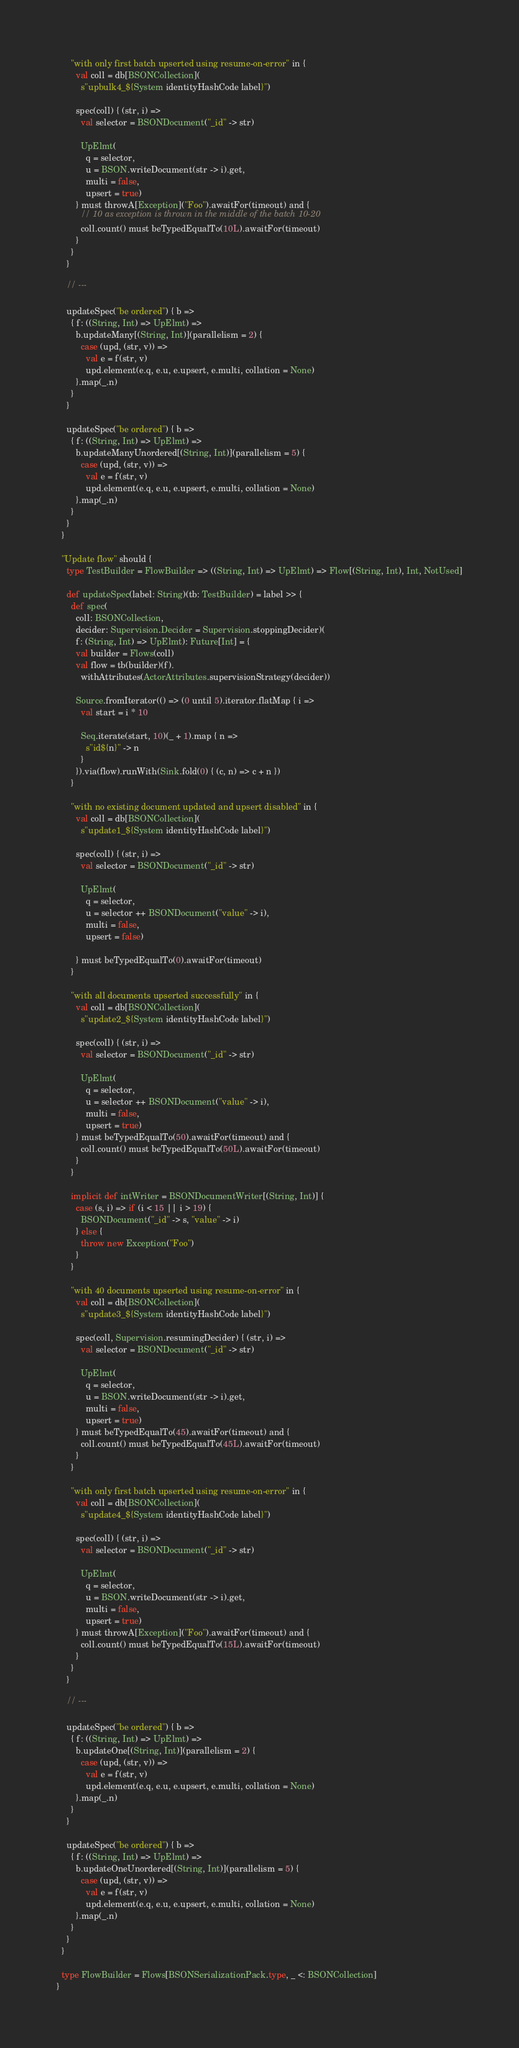<code> <loc_0><loc_0><loc_500><loc_500><_Scala_>
      "with only first batch upserted using resume-on-error" in {
        val coll = db[BSONCollection](
          s"upbulk4_${System identityHashCode label}")

        spec(coll) { (str, i) =>
          val selector = BSONDocument("_id" -> str)

          UpElmt(
            q = selector,
            u = BSON.writeDocument(str -> i).get,
            multi = false,
            upsert = true)
        } must throwA[Exception]("Foo").awaitFor(timeout) and {
          // 10 as exception is thrown in the middle of the batch 10-20
          coll.count() must beTypedEqualTo(10L).awaitFor(timeout)
        }
      }
    }

    // ---

    updateSpec("be ordered") { b =>
      { f: ((String, Int) => UpElmt) =>
        b.updateMany[(String, Int)](parallelism = 2) {
          case (upd, (str, v)) =>
            val e = f(str, v)
            upd.element(e.q, e.u, e.upsert, e.multi, collation = None)
        }.map(_.n)
      }
    }

    updateSpec("be ordered") { b =>
      { f: ((String, Int) => UpElmt) =>
        b.updateManyUnordered[(String, Int)](parallelism = 5) {
          case (upd, (str, v)) =>
            val e = f(str, v)
            upd.element(e.q, e.u, e.upsert, e.multi, collation = None)
        }.map(_.n)
      }
    }
  }

  "Update flow" should {
    type TestBuilder = FlowBuilder => ((String, Int) => UpElmt) => Flow[(String, Int), Int, NotUsed]

    def updateSpec(label: String)(tb: TestBuilder) = label >> {
      def spec(
        coll: BSONCollection,
        decider: Supervision.Decider = Supervision.stoppingDecider)(
        f: (String, Int) => UpElmt): Future[Int] = {
        val builder = Flows(coll)
        val flow = tb(builder)(f).
          withAttributes(ActorAttributes.supervisionStrategy(decider))

        Source.fromIterator(() => (0 until 5).iterator.flatMap { i =>
          val start = i * 10

          Seq.iterate(start, 10)(_ + 1).map { n =>
            s"id${n}" -> n
          }
        }).via(flow).runWith(Sink.fold(0) { (c, n) => c + n })
      }

      "with no existing document updated and upsert disabled" in {
        val coll = db[BSONCollection](
          s"update1_${System identityHashCode label}")

        spec(coll) { (str, i) =>
          val selector = BSONDocument("_id" -> str)

          UpElmt(
            q = selector,
            u = selector ++ BSONDocument("value" -> i),
            multi = false,
            upsert = false)

        } must beTypedEqualTo(0).awaitFor(timeout)
      }

      "with all documents upserted successfully" in {
        val coll = db[BSONCollection](
          s"update2_${System identityHashCode label}")

        spec(coll) { (str, i) =>
          val selector = BSONDocument("_id" -> str)

          UpElmt(
            q = selector,
            u = selector ++ BSONDocument("value" -> i),
            multi = false,
            upsert = true)
        } must beTypedEqualTo(50).awaitFor(timeout) and {
          coll.count() must beTypedEqualTo(50L).awaitFor(timeout)
        }
      }

      implicit def intWriter = BSONDocumentWriter[(String, Int)] {
        case (s, i) => if (i < 15 || i > 19) {
          BSONDocument("_id" -> s, "value" -> i)
        } else {
          throw new Exception("Foo")
        }
      }

      "with 40 documents upserted using resume-on-error" in {
        val coll = db[BSONCollection](
          s"update3_${System identityHashCode label}")

        spec(coll, Supervision.resumingDecider) { (str, i) =>
          val selector = BSONDocument("_id" -> str)

          UpElmt(
            q = selector,
            u = BSON.writeDocument(str -> i).get,
            multi = false,
            upsert = true)
        } must beTypedEqualTo(45).awaitFor(timeout) and {
          coll.count() must beTypedEqualTo(45L).awaitFor(timeout)
        }
      }

      "with only first batch upserted using resume-on-error" in {
        val coll = db[BSONCollection](
          s"update4_${System identityHashCode label}")

        spec(coll) { (str, i) =>
          val selector = BSONDocument("_id" -> str)

          UpElmt(
            q = selector,
            u = BSON.writeDocument(str -> i).get,
            multi = false,
            upsert = true)
        } must throwA[Exception]("Foo").awaitFor(timeout) and {
          coll.count() must beTypedEqualTo(15L).awaitFor(timeout)
        }
      }
    }

    // ---

    updateSpec("be ordered") { b =>
      { f: ((String, Int) => UpElmt) =>
        b.updateOne[(String, Int)](parallelism = 2) {
          case (upd, (str, v)) =>
            val e = f(str, v)
            upd.element(e.q, e.u, e.upsert, e.multi, collation = None)
        }.map(_.n)
      }
    }

    updateSpec("be ordered") { b =>
      { f: ((String, Int) => UpElmt) =>
        b.updateOneUnordered[(String, Int)](parallelism = 5) {
          case (upd, (str, v)) =>
            val e = f(str, v)
            upd.element(e.q, e.u, e.upsert, e.multi, collation = None)
        }.map(_.n)
      }
    }
  }

  type FlowBuilder = Flows[BSONSerializationPack.type, _ <: BSONCollection]
}
</code> 